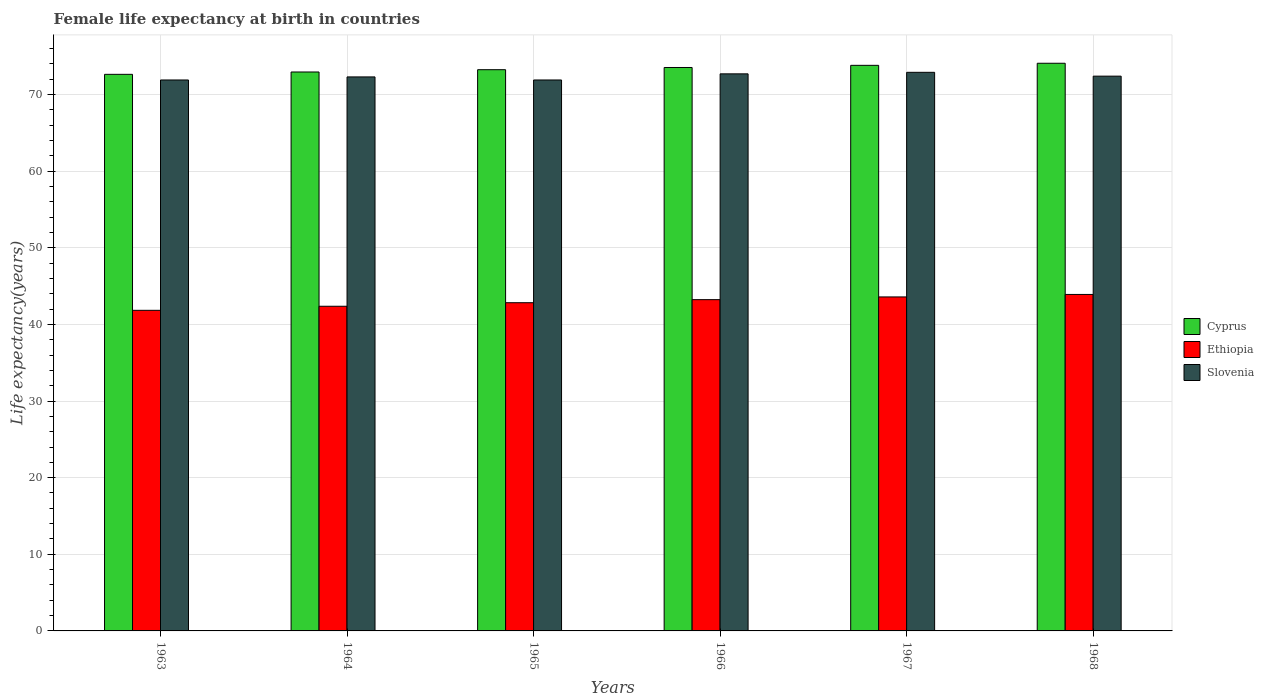Are the number of bars per tick equal to the number of legend labels?
Keep it short and to the point. Yes. What is the label of the 2nd group of bars from the left?
Provide a succinct answer. 1964. In how many cases, is the number of bars for a given year not equal to the number of legend labels?
Offer a terse response. 0. What is the female life expectancy at birth in Ethiopia in 1968?
Offer a terse response. 43.91. Across all years, what is the maximum female life expectancy at birth in Slovenia?
Your answer should be compact. 72.9. Across all years, what is the minimum female life expectancy at birth in Cyprus?
Your answer should be very brief. 72.64. In which year was the female life expectancy at birth in Slovenia maximum?
Provide a short and direct response. 1967. What is the total female life expectancy at birth in Ethiopia in the graph?
Provide a short and direct response. 257.77. What is the difference between the female life expectancy at birth in Cyprus in 1963 and that in 1968?
Your answer should be very brief. -1.45. What is the difference between the female life expectancy at birth in Cyprus in 1963 and the female life expectancy at birth in Ethiopia in 1967?
Provide a succinct answer. 29.05. What is the average female life expectancy at birth in Slovenia per year?
Ensure brevity in your answer.  72.35. In the year 1966, what is the difference between the female life expectancy at birth in Ethiopia and female life expectancy at birth in Cyprus?
Provide a succinct answer. -30.3. What is the ratio of the female life expectancy at birth in Ethiopia in 1965 to that in 1967?
Make the answer very short. 0.98. Is the female life expectancy at birth in Slovenia in 1964 less than that in 1965?
Offer a very short reply. No. What is the difference between the highest and the second highest female life expectancy at birth in Slovenia?
Your response must be concise. 0.2. What is the difference between the highest and the lowest female life expectancy at birth in Slovenia?
Your answer should be very brief. 1. In how many years, is the female life expectancy at birth in Slovenia greater than the average female life expectancy at birth in Slovenia taken over all years?
Your response must be concise. 3. What does the 3rd bar from the left in 1966 represents?
Make the answer very short. Slovenia. What does the 2nd bar from the right in 1963 represents?
Your answer should be compact. Ethiopia. Is it the case that in every year, the sum of the female life expectancy at birth in Ethiopia and female life expectancy at birth in Slovenia is greater than the female life expectancy at birth in Cyprus?
Your response must be concise. Yes. How many bars are there?
Ensure brevity in your answer.  18. Are all the bars in the graph horizontal?
Give a very brief answer. No. How many years are there in the graph?
Your answer should be compact. 6. Are the values on the major ticks of Y-axis written in scientific E-notation?
Make the answer very short. No. Does the graph contain grids?
Offer a terse response. Yes. Where does the legend appear in the graph?
Give a very brief answer. Center right. What is the title of the graph?
Your response must be concise. Female life expectancy at birth in countries. Does "Spain" appear as one of the legend labels in the graph?
Make the answer very short. No. What is the label or title of the Y-axis?
Make the answer very short. Life expectancy(years). What is the Life expectancy(years) in Cyprus in 1963?
Your response must be concise. 72.64. What is the Life expectancy(years) in Ethiopia in 1963?
Offer a very short reply. 41.84. What is the Life expectancy(years) in Slovenia in 1963?
Offer a terse response. 71.9. What is the Life expectancy(years) in Cyprus in 1964?
Make the answer very short. 72.94. What is the Life expectancy(years) in Ethiopia in 1964?
Your answer should be very brief. 42.37. What is the Life expectancy(years) of Slovenia in 1964?
Offer a very short reply. 72.3. What is the Life expectancy(years) of Cyprus in 1965?
Your response must be concise. 73.24. What is the Life expectancy(years) in Ethiopia in 1965?
Make the answer very short. 42.83. What is the Life expectancy(years) in Slovenia in 1965?
Keep it short and to the point. 71.9. What is the Life expectancy(years) of Cyprus in 1966?
Ensure brevity in your answer.  73.53. What is the Life expectancy(years) in Ethiopia in 1966?
Offer a very short reply. 43.23. What is the Life expectancy(years) in Slovenia in 1966?
Ensure brevity in your answer.  72.7. What is the Life expectancy(years) of Cyprus in 1967?
Your answer should be very brief. 73.81. What is the Life expectancy(years) in Ethiopia in 1967?
Provide a succinct answer. 43.59. What is the Life expectancy(years) of Slovenia in 1967?
Your answer should be compact. 72.9. What is the Life expectancy(years) in Cyprus in 1968?
Ensure brevity in your answer.  74.08. What is the Life expectancy(years) in Ethiopia in 1968?
Your answer should be compact. 43.91. What is the Life expectancy(years) in Slovenia in 1968?
Your answer should be compact. 72.4. Across all years, what is the maximum Life expectancy(years) in Cyprus?
Your answer should be compact. 74.08. Across all years, what is the maximum Life expectancy(years) of Ethiopia?
Provide a short and direct response. 43.91. Across all years, what is the maximum Life expectancy(years) in Slovenia?
Your answer should be very brief. 72.9. Across all years, what is the minimum Life expectancy(years) in Cyprus?
Your response must be concise. 72.64. Across all years, what is the minimum Life expectancy(years) in Ethiopia?
Offer a terse response. 41.84. Across all years, what is the minimum Life expectancy(years) of Slovenia?
Ensure brevity in your answer.  71.9. What is the total Life expectancy(years) in Cyprus in the graph?
Keep it short and to the point. 440.24. What is the total Life expectancy(years) in Ethiopia in the graph?
Your response must be concise. 257.77. What is the total Life expectancy(years) of Slovenia in the graph?
Keep it short and to the point. 434.1. What is the difference between the Life expectancy(years) of Cyprus in 1963 and that in 1964?
Make the answer very short. -0.31. What is the difference between the Life expectancy(years) of Ethiopia in 1963 and that in 1964?
Offer a terse response. -0.53. What is the difference between the Life expectancy(years) of Cyprus in 1963 and that in 1965?
Ensure brevity in your answer.  -0.6. What is the difference between the Life expectancy(years) in Ethiopia in 1963 and that in 1965?
Provide a succinct answer. -0.99. What is the difference between the Life expectancy(years) of Cyprus in 1963 and that in 1966?
Keep it short and to the point. -0.89. What is the difference between the Life expectancy(years) in Ethiopia in 1963 and that in 1966?
Your response must be concise. -1.39. What is the difference between the Life expectancy(years) of Cyprus in 1963 and that in 1967?
Ensure brevity in your answer.  -1.17. What is the difference between the Life expectancy(years) in Ethiopia in 1963 and that in 1967?
Your answer should be compact. -1.75. What is the difference between the Life expectancy(years) of Slovenia in 1963 and that in 1967?
Keep it short and to the point. -1. What is the difference between the Life expectancy(years) in Cyprus in 1963 and that in 1968?
Provide a succinct answer. -1.45. What is the difference between the Life expectancy(years) in Ethiopia in 1963 and that in 1968?
Give a very brief answer. -2.07. What is the difference between the Life expectancy(years) in Slovenia in 1963 and that in 1968?
Your answer should be compact. -0.5. What is the difference between the Life expectancy(years) in Cyprus in 1964 and that in 1965?
Your answer should be compact. -0.3. What is the difference between the Life expectancy(years) in Ethiopia in 1964 and that in 1965?
Ensure brevity in your answer.  -0.46. What is the difference between the Life expectancy(years) of Slovenia in 1964 and that in 1965?
Offer a terse response. 0.4. What is the difference between the Life expectancy(years) in Cyprus in 1964 and that in 1966?
Your response must be concise. -0.59. What is the difference between the Life expectancy(years) in Ethiopia in 1964 and that in 1966?
Your response must be concise. -0.86. What is the difference between the Life expectancy(years) in Slovenia in 1964 and that in 1966?
Keep it short and to the point. -0.4. What is the difference between the Life expectancy(years) in Cyprus in 1964 and that in 1967?
Your answer should be very brief. -0.87. What is the difference between the Life expectancy(years) in Ethiopia in 1964 and that in 1967?
Offer a very short reply. -1.22. What is the difference between the Life expectancy(years) in Slovenia in 1964 and that in 1967?
Give a very brief answer. -0.6. What is the difference between the Life expectancy(years) in Cyprus in 1964 and that in 1968?
Your answer should be compact. -1.14. What is the difference between the Life expectancy(years) of Ethiopia in 1964 and that in 1968?
Your response must be concise. -1.54. What is the difference between the Life expectancy(years) of Slovenia in 1964 and that in 1968?
Your answer should be very brief. -0.1. What is the difference between the Life expectancy(years) in Cyprus in 1965 and that in 1966?
Your answer should be compact. -0.29. What is the difference between the Life expectancy(years) of Ethiopia in 1965 and that in 1966?
Offer a terse response. -0.4. What is the difference between the Life expectancy(years) of Cyprus in 1965 and that in 1967?
Offer a terse response. -0.57. What is the difference between the Life expectancy(years) in Ethiopia in 1965 and that in 1967?
Make the answer very short. -0.76. What is the difference between the Life expectancy(years) in Cyprus in 1965 and that in 1968?
Provide a succinct answer. -0.84. What is the difference between the Life expectancy(years) of Ethiopia in 1965 and that in 1968?
Your answer should be compact. -1.08. What is the difference between the Life expectancy(years) of Slovenia in 1965 and that in 1968?
Give a very brief answer. -0.5. What is the difference between the Life expectancy(years) in Cyprus in 1966 and that in 1967?
Provide a short and direct response. -0.28. What is the difference between the Life expectancy(years) in Ethiopia in 1966 and that in 1967?
Provide a succinct answer. -0.36. What is the difference between the Life expectancy(years) of Cyprus in 1966 and that in 1968?
Keep it short and to the point. -0.55. What is the difference between the Life expectancy(years) in Ethiopia in 1966 and that in 1968?
Provide a short and direct response. -0.68. What is the difference between the Life expectancy(years) of Slovenia in 1966 and that in 1968?
Provide a short and direct response. 0.3. What is the difference between the Life expectancy(years) in Cyprus in 1967 and that in 1968?
Your answer should be very brief. -0.27. What is the difference between the Life expectancy(years) of Ethiopia in 1967 and that in 1968?
Your answer should be compact. -0.32. What is the difference between the Life expectancy(years) in Slovenia in 1967 and that in 1968?
Make the answer very short. 0.5. What is the difference between the Life expectancy(years) of Cyprus in 1963 and the Life expectancy(years) of Ethiopia in 1964?
Your answer should be very brief. 30.27. What is the difference between the Life expectancy(years) in Cyprus in 1963 and the Life expectancy(years) in Slovenia in 1964?
Make the answer very short. 0.34. What is the difference between the Life expectancy(years) in Ethiopia in 1963 and the Life expectancy(years) in Slovenia in 1964?
Your response must be concise. -30.46. What is the difference between the Life expectancy(years) in Cyprus in 1963 and the Life expectancy(years) in Ethiopia in 1965?
Your response must be concise. 29.8. What is the difference between the Life expectancy(years) of Cyprus in 1963 and the Life expectancy(years) of Slovenia in 1965?
Provide a succinct answer. 0.74. What is the difference between the Life expectancy(years) in Ethiopia in 1963 and the Life expectancy(years) in Slovenia in 1965?
Provide a succinct answer. -30.06. What is the difference between the Life expectancy(years) in Cyprus in 1963 and the Life expectancy(years) in Ethiopia in 1966?
Provide a short and direct response. 29.4. What is the difference between the Life expectancy(years) in Cyprus in 1963 and the Life expectancy(years) in Slovenia in 1966?
Make the answer very short. -0.06. What is the difference between the Life expectancy(years) in Ethiopia in 1963 and the Life expectancy(years) in Slovenia in 1966?
Keep it short and to the point. -30.86. What is the difference between the Life expectancy(years) in Cyprus in 1963 and the Life expectancy(years) in Ethiopia in 1967?
Ensure brevity in your answer.  29.05. What is the difference between the Life expectancy(years) of Cyprus in 1963 and the Life expectancy(years) of Slovenia in 1967?
Give a very brief answer. -0.26. What is the difference between the Life expectancy(years) in Ethiopia in 1963 and the Life expectancy(years) in Slovenia in 1967?
Offer a terse response. -31.06. What is the difference between the Life expectancy(years) in Cyprus in 1963 and the Life expectancy(years) in Ethiopia in 1968?
Give a very brief answer. 28.72. What is the difference between the Life expectancy(years) in Cyprus in 1963 and the Life expectancy(years) in Slovenia in 1968?
Provide a succinct answer. 0.24. What is the difference between the Life expectancy(years) of Ethiopia in 1963 and the Life expectancy(years) of Slovenia in 1968?
Ensure brevity in your answer.  -30.56. What is the difference between the Life expectancy(years) of Cyprus in 1964 and the Life expectancy(years) of Ethiopia in 1965?
Your answer should be very brief. 30.11. What is the difference between the Life expectancy(years) in Cyprus in 1964 and the Life expectancy(years) in Slovenia in 1965?
Provide a short and direct response. 1.04. What is the difference between the Life expectancy(years) in Ethiopia in 1964 and the Life expectancy(years) in Slovenia in 1965?
Make the answer very short. -29.53. What is the difference between the Life expectancy(years) in Cyprus in 1964 and the Life expectancy(years) in Ethiopia in 1966?
Offer a terse response. 29.71. What is the difference between the Life expectancy(years) in Cyprus in 1964 and the Life expectancy(years) in Slovenia in 1966?
Your answer should be compact. 0.24. What is the difference between the Life expectancy(years) of Ethiopia in 1964 and the Life expectancy(years) of Slovenia in 1966?
Your answer should be compact. -30.33. What is the difference between the Life expectancy(years) in Cyprus in 1964 and the Life expectancy(years) in Ethiopia in 1967?
Your response must be concise. 29.36. What is the difference between the Life expectancy(years) in Cyprus in 1964 and the Life expectancy(years) in Slovenia in 1967?
Offer a terse response. 0.04. What is the difference between the Life expectancy(years) in Ethiopia in 1964 and the Life expectancy(years) in Slovenia in 1967?
Ensure brevity in your answer.  -30.53. What is the difference between the Life expectancy(years) of Cyprus in 1964 and the Life expectancy(years) of Ethiopia in 1968?
Your answer should be compact. 29.03. What is the difference between the Life expectancy(years) in Cyprus in 1964 and the Life expectancy(years) in Slovenia in 1968?
Your response must be concise. 0.54. What is the difference between the Life expectancy(years) of Ethiopia in 1964 and the Life expectancy(years) of Slovenia in 1968?
Your response must be concise. -30.03. What is the difference between the Life expectancy(years) in Cyprus in 1965 and the Life expectancy(years) in Ethiopia in 1966?
Your answer should be very brief. 30.01. What is the difference between the Life expectancy(years) of Cyprus in 1965 and the Life expectancy(years) of Slovenia in 1966?
Your response must be concise. 0.54. What is the difference between the Life expectancy(years) of Ethiopia in 1965 and the Life expectancy(years) of Slovenia in 1966?
Ensure brevity in your answer.  -29.87. What is the difference between the Life expectancy(years) of Cyprus in 1965 and the Life expectancy(years) of Ethiopia in 1967?
Your answer should be compact. 29.65. What is the difference between the Life expectancy(years) of Cyprus in 1965 and the Life expectancy(years) of Slovenia in 1967?
Give a very brief answer. 0.34. What is the difference between the Life expectancy(years) of Ethiopia in 1965 and the Life expectancy(years) of Slovenia in 1967?
Provide a short and direct response. -30.07. What is the difference between the Life expectancy(years) in Cyprus in 1965 and the Life expectancy(years) in Ethiopia in 1968?
Your response must be concise. 29.33. What is the difference between the Life expectancy(years) of Cyprus in 1965 and the Life expectancy(years) of Slovenia in 1968?
Keep it short and to the point. 0.84. What is the difference between the Life expectancy(years) of Ethiopia in 1965 and the Life expectancy(years) of Slovenia in 1968?
Provide a short and direct response. -29.57. What is the difference between the Life expectancy(years) of Cyprus in 1966 and the Life expectancy(years) of Ethiopia in 1967?
Give a very brief answer. 29.94. What is the difference between the Life expectancy(years) in Cyprus in 1966 and the Life expectancy(years) in Slovenia in 1967?
Offer a very short reply. 0.63. What is the difference between the Life expectancy(years) of Ethiopia in 1966 and the Life expectancy(years) of Slovenia in 1967?
Your answer should be compact. -29.67. What is the difference between the Life expectancy(years) in Cyprus in 1966 and the Life expectancy(years) in Ethiopia in 1968?
Offer a very short reply. 29.62. What is the difference between the Life expectancy(years) of Cyprus in 1966 and the Life expectancy(years) of Slovenia in 1968?
Your answer should be very brief. 1.13. What is the difference between the Life expectancy(years) in Ethiopia in 1966 and the Life expectancy(years) in Slovenia in 1968?
Your response must be concise. -29.17. What is the difference between the Life expectancy(years) of Cyprus in 1967 and the Life expectancy(years) of Ethiopia in 1968?
Your answer should be very brief. 29.9. What is the difference between the Life expectancy(years) of Cyprus in 1967 and the Life expectancy(years) of Slovenia in 1968?
Offer a terse response. 1.41. What is the difference between the Life expectancy(years) in Ethiopia in 1967 and the Life expectancy(years) in Slovenia in 1968?
Make the answer very short. -28.81. What is the average Life expectancy(years) in Cyprus per year?
Keep it short and to the point. 73.37. What is the average Life expectancy(years) of Ethiopia per year?
Keep it short and to the point. 42.96. What is the average Life expectancy(years) of Slovenia per year?
Provide a succinct answer. 72.35. In the year 1963, what is the difference between the Life expectancy(years) in Cyprus and Life expectancy(years) in Ethiopia?
Ensure brevity in your answer.  30.8. In the year 1963, what is the difference between the Life expectancy(years) in Cyprus and Life expectancy(years) in Slovenia?
Ensure brevity in your answer.  0.74. In the year 1963, what is the difference between the Life expectancy(years) in Ethiopia and Life expectancy(years) in Slovenia?
Give a very brief answer. -30.06. In the year 1964, what is the difference between the Life expectancy(years) of Cyprus and Life expectancy(years) of Ethiopia?
Ensure brevity in your answer.  30.57. In the year 1964, what is the difference between the Life expectancy(years) of Cyprus and Life expectancy(years) of Slovenia?
Your answer should be compact. 0.64. In the year 1964, what is the difference between the Life expectancy(years) of Ethiopia and Life expectancy(years) of Slovenia?
Your answer should be compact. -29.93. In the year 1965, what is the difference between the Life expectancy(years) in Cyprus and Life expectancy(years) in Ethiopia?
Keep it short and to the point. 30.41. In the year 1965, what is the difference between the Life expectancy(years) of Cyprus and Life expectancy(years) of Slovenia?
Offer a very short reply. 1.34. In the year 1965, what is the difference between the Life expectancy(years) of Ethiopia and Life expectancy(years) of Slovenia?
Give a very brief answer. -29.07. In the year 1966, what is the difference between the Life expectancy(years) in Cyprus and Life expectancy(years) in Ethiopia?
Offer a terse response. 30.3. In the year 1966, what is the difference between the Life expectancy(years) in Cyprus and Life expectancy(years) in Slovenia?
Provide a short and direct response. 0.83. In the year 1966, what is the difference between the Life expectancy(years) of Ethiopia and Life expectancy(years) of Slovenia?
Offer a terse response. -29.47. In the year 1967, what is the difference between the Life expectancy(years) of Cyprus and Life expectancy(years) of Ethiopia?
Your response must be concise. 30.22. In the year 1967, what is the difference between the Life expectancy(years) in Cyprus and Life expectancy(years) in Slovenia?
Your response must be concise. 0.91. In the year 1967, what is the difference between the Life expectancy(years) of Ethiopia and Life expectancy(years) of Slovenia?
Offer a very short reply. -29.31. In the year 1968, what is the difference between the Life expectancy(years) in Cyprus and Life expectancy(years) in Ethiopia?
Your answer should be very brief. 30.17. In the year 1968, what is the difference between the Life expectancy(years) in Cyprus and Life expectancy(years) in Slovenia?
Ensure brevity in your answer.  1.68. In the year 1968, what is the difference between the Life expectancy(years) in Ethiopia and Life expectancy(years) in Slovenia?
Keep it short and to the point. -28.49. What is the ratio of the Life expectancy(years) of Ethiopia in 1963 to that in 1964?
Your answer should be very brief. 0.99. What is the ratio of the Life expectancy(years) of Slovenia in 1963 to that in 1964?
Keep it short and to the point. 0.99. What is the ratio of the Life expectancy(years) in Cyprus in 1963 to that in 1965?
Offer a very short reply. 0.99. What is the ratio of the Life expectancy(years) in Ethiopia in 1963 to that in 1965?
Make the answer very short. 0.98. What is the ratio of the Life expectancy(years) in Ethiopia in 1963 to that in 1966?
Provide a succinct answer. 0.97. What is the ratio of the Life expectancy(years) in Cyprus in 1963 to that in 1967?
Your answer should be compact. 0.98. What is the ratio of the Life expectancy(years) of Ethiopia in 1963 to that in 1967?
Keep it short and to the point. 0.96. What is the ratio of the Life expectancy(years) in Slovenia in 1963 to that in 1967?
Offer a terse response. 0.99. What is the ratio of the Life expectancy(years) in Cyprus in 1963 to that in 1968?
Offer a very short reply. 0.98. What is the ratio of the Life expectancy(years) of Ethiopia in 1963 to that in 1968?
Give a very brief answer. 0.95. What is the ratio of the Life expectancy(years) of Slovenia in 1963 to that in 1968?
Keep it short and to the point. 0.99. What is the ratio of the Life expectancy(years) of Slovenia in 1964 to that in 1965?
Your response must be concise. 1.01. What is the ratio of the Life expectancy(years) of Cyprus in 1964 to that in 1966?
Provide a short and direct response. 0.99. What is the ratio of the Life expectancy(years) of Ethiopia in 1964 to that in 1966?
Your answer should be compact. 0.98. What is the ratio of the Life expectancy(years) of Slovenia in 1964 to that in 1966?
Offer a terse response. 0.99. What is the ratio of the Life expectancy(years) in Cyprus in 1964 to that in 1967?
Your response must be concise. 0.99. What is the ratio of the Life expectancy(years) in Ethiopia in 1964 to that in 1967?
Ensure brevity in your answer.  0.97. What is the ratio of the Life expectancy(years) in Cyprus in 1964 to that in 1968?
Offer a terse response. 0.98. What is the ratio of the Life expectancy(years) of Ethiopia in 1964 to that in 1968?
Ensure brevity in your answer.  0.96. What is the ratio of the Life expectancy(years) in Ethiopia in 1965 to that in 1966?
Provide a succinct answer. 0.99. What is the ratio of the Life expectancy(years) in Cyprus in 1965 to that in 1967?
Keep it short and to the point. 0.99. What is the ratio of the Life expectancy(years) of Ethiopia in 1965 to that in 1967?
Provide a short and direct response. 0.98. What is the ratio of the Life expectancy(years) in Slovenia in 1965 to that in 1967?
Offer a very short reply. 0.99. What is the ratio of the Life expectancy(years) in Ethiopia in 1965 to that in 1968?
Provide a succinct answer. 0.98. What is the ratio of the Life expectancy(years) of Slovenia in 1965 to that in 1968?
Offer a terse response. 0.99. What is the ratio of the Life expectancy(years) of Cyprus in 1966 to that in 1967?
Provide a succinct answer. 1. What is the ratio of the Life expectancy(years) in Ethiopia in 1966 to that in 1967?
Provide a short and direct response. 0.99. What is the ratio of the Life expectancy(years) in Ethiopia in 1966 to that in 1968?
Give a very brief answer. 0.98. What is the ratio of the Life expectancy(years) in Slovenia in 1966 to that in 1968?
Make the answer very short. 1. What is the difference between the highest and the second highest Life expectancy(years) of Cyprus?
Make the answer very short. 0.27. What is the difference between the highest and the second highest Life expectancy(years) in Ethiopia?
Offer a very short reply. 0.32. What is the difference between the highest and the lowest Life expectancy(years) in Cyprus?
Your answer should be compact. 1.45. What is the difference between the highest and the lowest Life expectancy(years) in Ethiopia?
Offer a terse response. 2.07. 